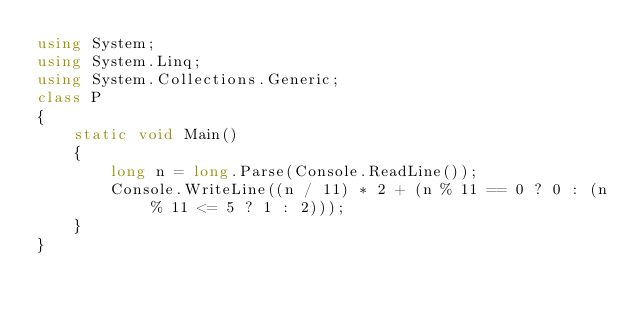<code> <loc_0><loc_0><loc_500><loc_500><_C#_>using System;
using System.Linq;
using System.Collections.Generic;
class P
{
    static void Main()
    {
        long n = long.Parse(Console.ReadLine());
        Console.WriteLine((n / 11) * 2 + (n % 11 == 0 ? 0 : (n % 11 <= 5 ? 1 : 2)));
    }
}
</code> 